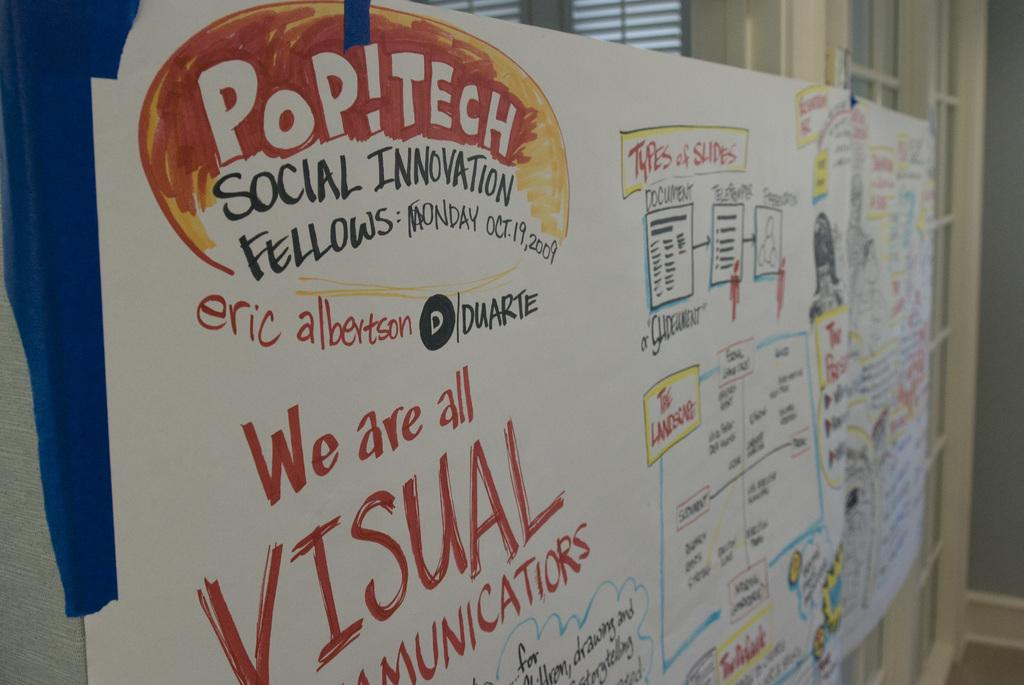<image>
Render a clear and concise summary of the photo. a POP!TECH Social Invitation sign with lots of other writing on it. 